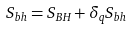<formula> <loc_0><loc_0><loc_500><loc_500>S _ { b h } = S _ { B H } + \delta _ { q } S _ { b h }</formula> 